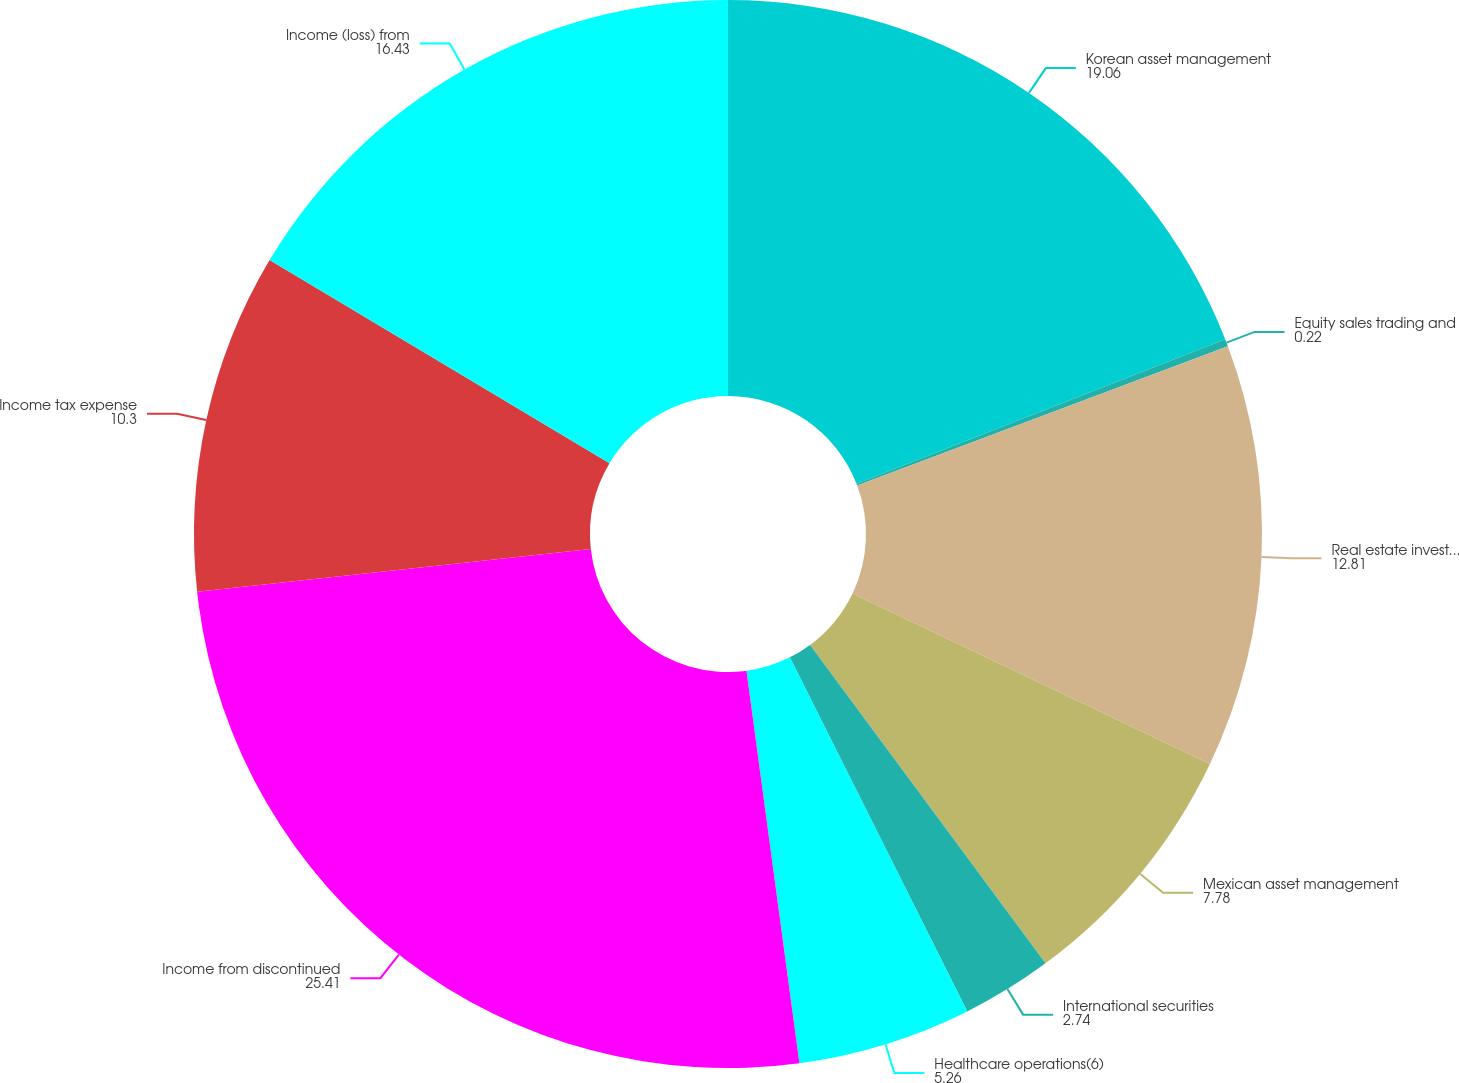Convert chart. <chart><loc_0><loc_0><loc_500><loc_500><pie_chart><fcel>Korean asset management<fcel>Equity sales trading and<fcel>Real estate investments sold<fcel>Mexican asset management<fcel>International securities<fcel>Healthcare operations(6)<fcel>Income from discontinued<fcel>Income tax expense<fcel>Income (loss) from<nl><fcel>19.06%<fcel>0.22%<fcel>12.81%<fcel>7.78%<fcel>2.74%<fcel>5.26%<fcel>25.41%<fcel>10.3%<fcel>16.43%<nl></chart> 